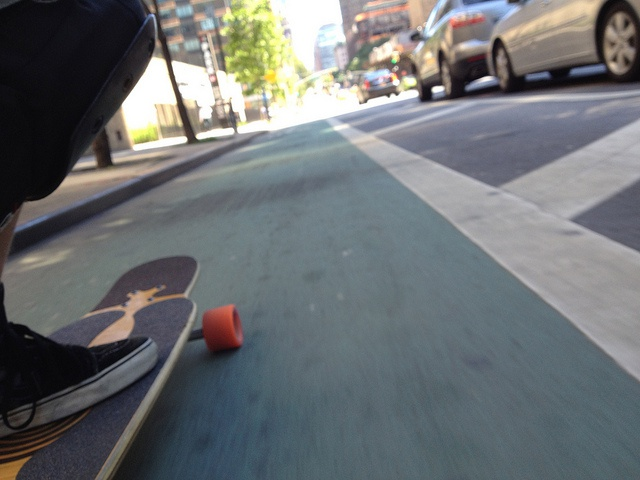Describe the objects in this image and their specific colors. I can see people in black, gray, and darkgray tones, skateboard in black and gray tones, car in black, darkgray, and gray tones, car in black, gray, and darkgray tones, and car in black, white, gray, darkgray, and tan tones in this image. 